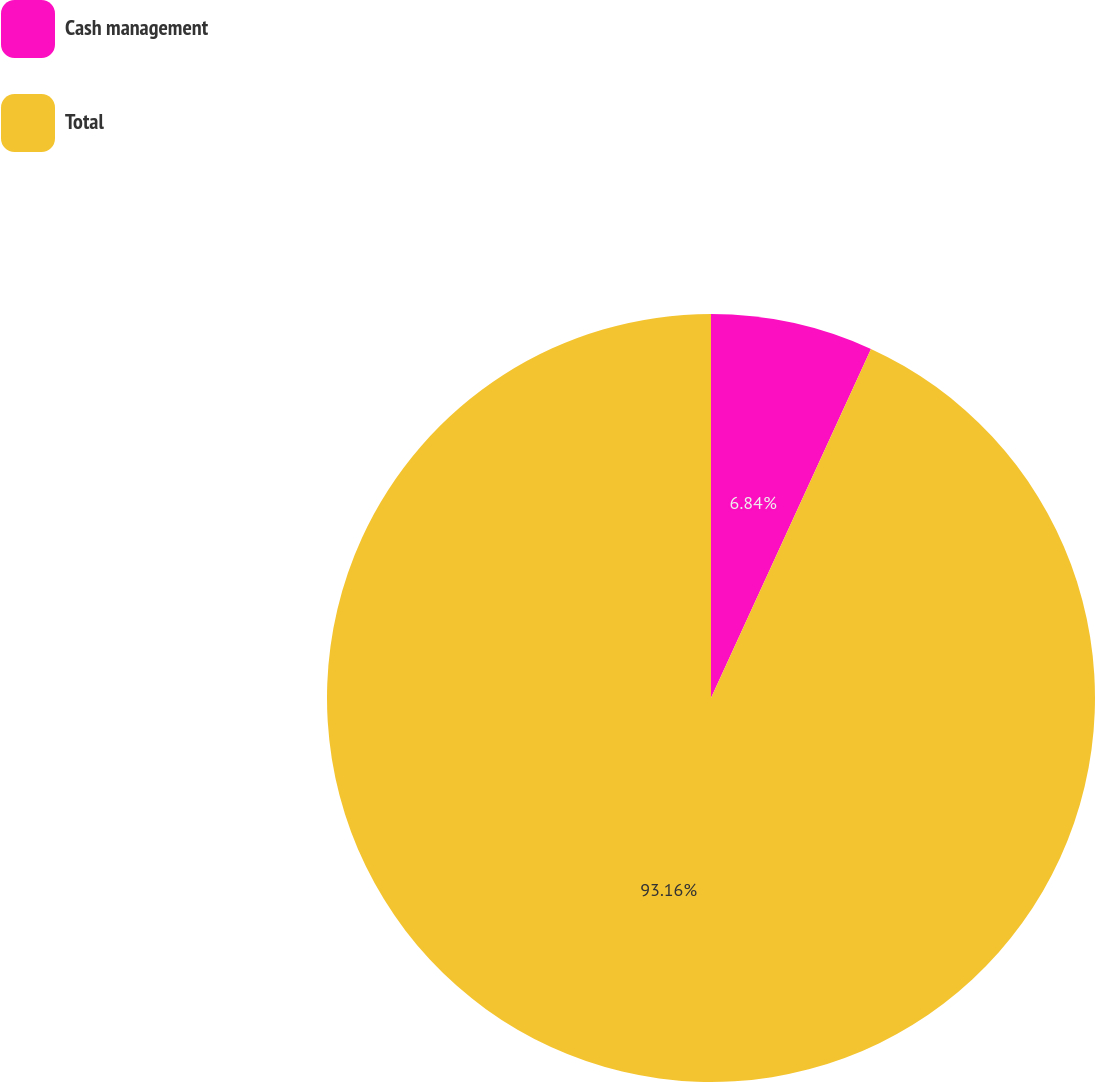Convert chart to OTSL. <chart><loc_0><loc_0><loc_500><loc_500><pie_chart><fcel>Cash management<fcel>Total<nl><fcel>6.84%<fcel>93.16%<nl></chart> 